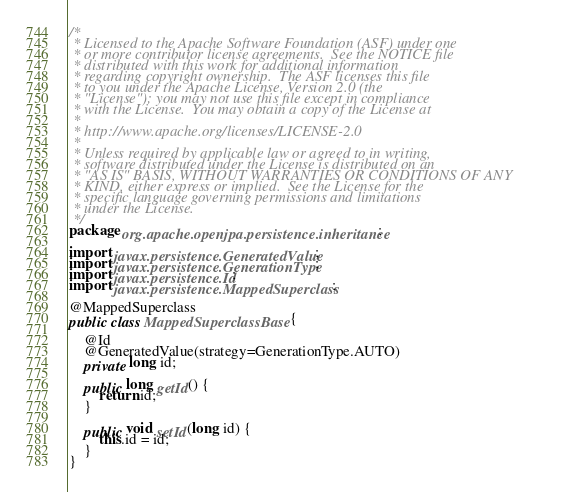<code> <loc_0><loc_0><loc_500><loc_500><_Java_>/*
 * Licensed to the Apache Software Foundation (ASF) under one
 * or more contributor license agreements.  See the NOTICE file
 * distributed with this work for additional information
 * regarding copyright ownership.  The ASF licenses this file
 * to you under the Apache License, Version 2.0 (the
 * "License"); you may not use this file except in compliance
 * with the License.  You may obtain a copy of the License at
 *
 * http://www.apache.org/licenses/LICENSE-2.0
 *
 * Unless required by applicable law or agreed to in writing,
 * software distributed under the License is distributed on an
 * "AS IS" BASIS, WITHOUT WARRANTIES OR CONDITIONS OF ANY
 * KIND, either express or implied.  See the License for the
 * specific language governing permissions and limitations
 * under the License.
 */
package org.apache.openjpa.persistence.inheritance;

import javax.persistence.GeneratedValue;
import javax.persistence.GenerationType;
import javax.persistence.Id;
import javax.persistence.MappedSuperclass;

@MappedSuperclass
public class MappedSuperclassBase {

    @Id
    @GeneratedValue(strategy=GenerationType.AUTO)
    private long id;

    public long getId() {
        return id;
    }

    public void setId(long id) {
        this.id = id;
    }
}

</code> 